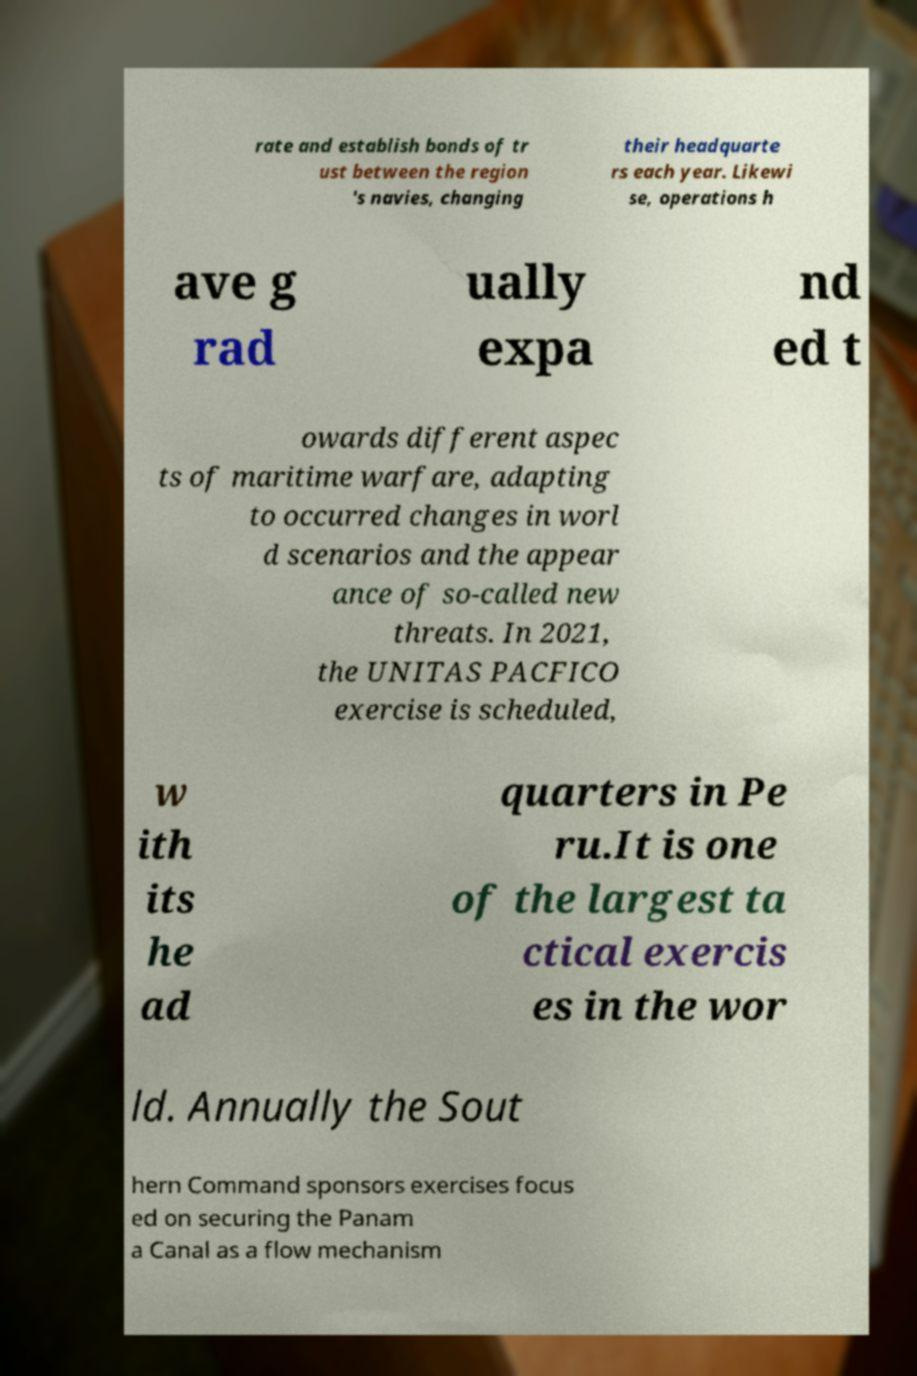Please identify and transcribe the text found in this image. rate and establish bonds of tr ust between the region 's navies, changing their headquarte rs each year. Likewi se, operations h ave g rad ually expa nd ed t owards different aspec ts of maritime warfare, adapting to occurred changes in worl d scenarios and the appear ance of so-called new threats. In 2021, the UNITAS PACFICO exercise is scheduled, w ith its he ad quarters in Pe ru.It is one of the largest ta ctical exercis es in the wor ld. Annually the Sout hern Command sponsors exercises focus ed on securing the Panam a Canal as a flow mechanism 